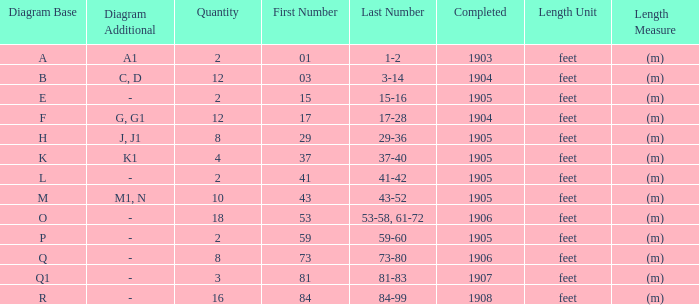For the item with more than 10, and numbers of 53-58, 61-72, what is the lowest completed? 1906.0. 